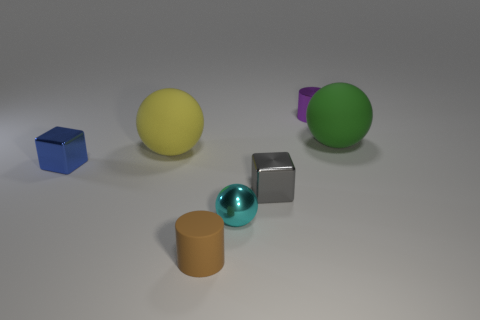There is a small shiny thing that is behind the small blue thing; does it have the same color as the matte cylinder?
Give a very brief answer. No. Is there a large yellow thing that has the same shape as the tiny brown matte object?
Give a very brief answer. No. There is a metallic ball that is the same size as the gray metal cube; what color is it?
Offer a very short reply. Cyan. How big is the rubber sphere to the right of the purple thing?
Give a very brief answer. Large. There is a large object to the right of the purple metallic cylinder; are there any brown rubber objects that are behind it?
Offer a very short reply. No. Do the sphere right of the purple cylinder and the tiny brown object have the same material?
Keep it short and to the point. Yes. What number of matte objects are on the left side of the tiny brown rubber cylinder and right of the small purple shiny cylinder?
Ensure brevity in your answer.  0. What number of gray objects have the same material as the blue thing?
Offer a terse response. 1. The cylinder that is made of the same material as the gray cube is what color?
Make the answer very short. Purple. Is the number of small gray objects less than the number of brown metal objects?
Offer a very short reply. No. 